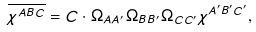Convert formula to latex. <formula><loc_0><loc_0><loc_500><loc_500>\overline { \chi ^ { A B C } } = C \cdot \Omega _ { A A ^ { \prime } } \Omega _ { B B ^ { \prime } } \Omega _ { C C ^ { \prime } } \chi ^ { A ^ { \prime } B ^ { \prime } C ^ { \prime } } ,</formula> 